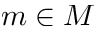Convert formula to latex. <formula><loc_0><loc_0><loc_500><loc_500>m \in M</formula> 